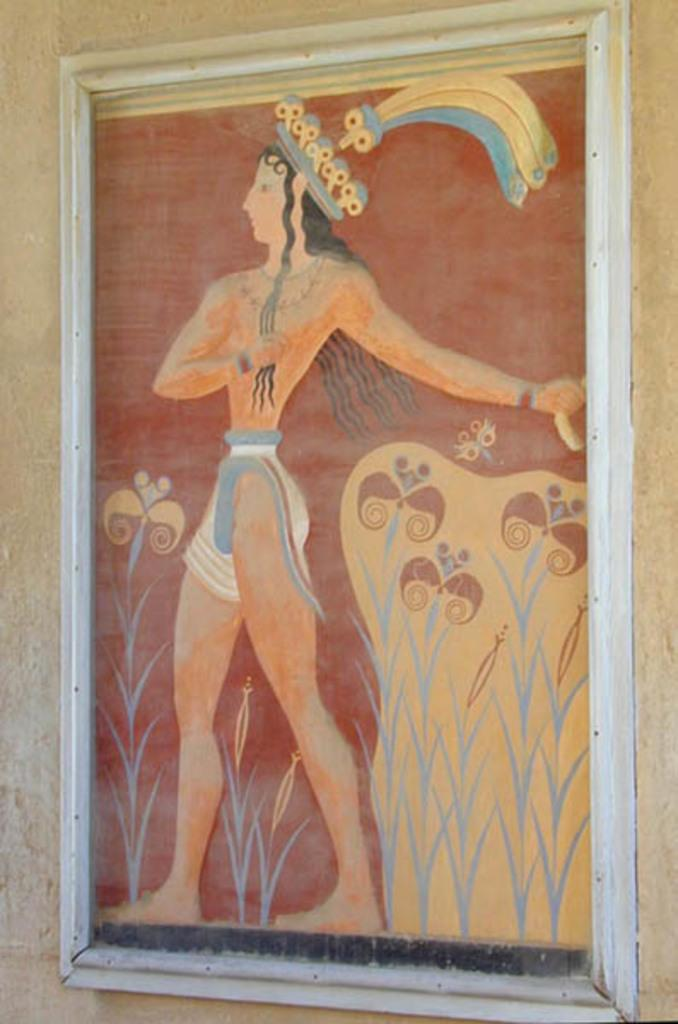What is on the wall in the image? There is a frame on the wall in the image. What can be seen inside the frame? There is a person depicted on the frame. What type of mist surrounds the person in the frame? There is no mist present in the image; it is a frame with a person depicted on it. 